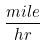<formula> <loc_0><loc_0><loc_500><loc_500>\frac { m i l e } { h r }</formula> 